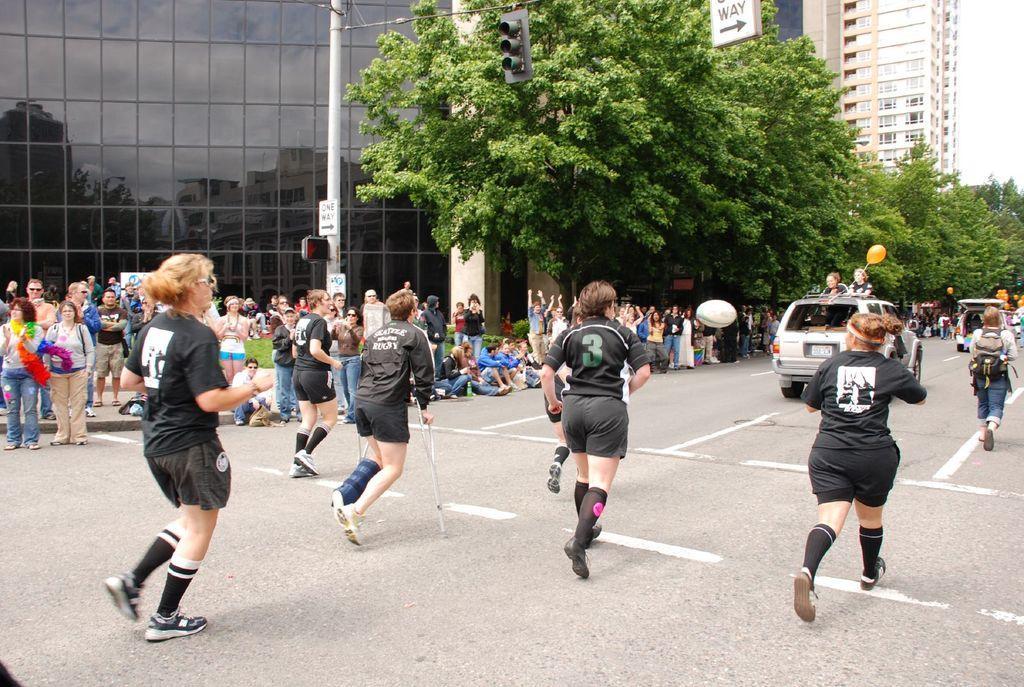Please provide a concise description of this image. In this image we can see a group of people wearing dress is standing on the road and some people are sitting on the ground. To the right side of the image we can see some vehicles parked on road, group of balloons. In the background, we can see traffic lights and sign boards on a pole, group of trees, buildings with windows and the sky. 